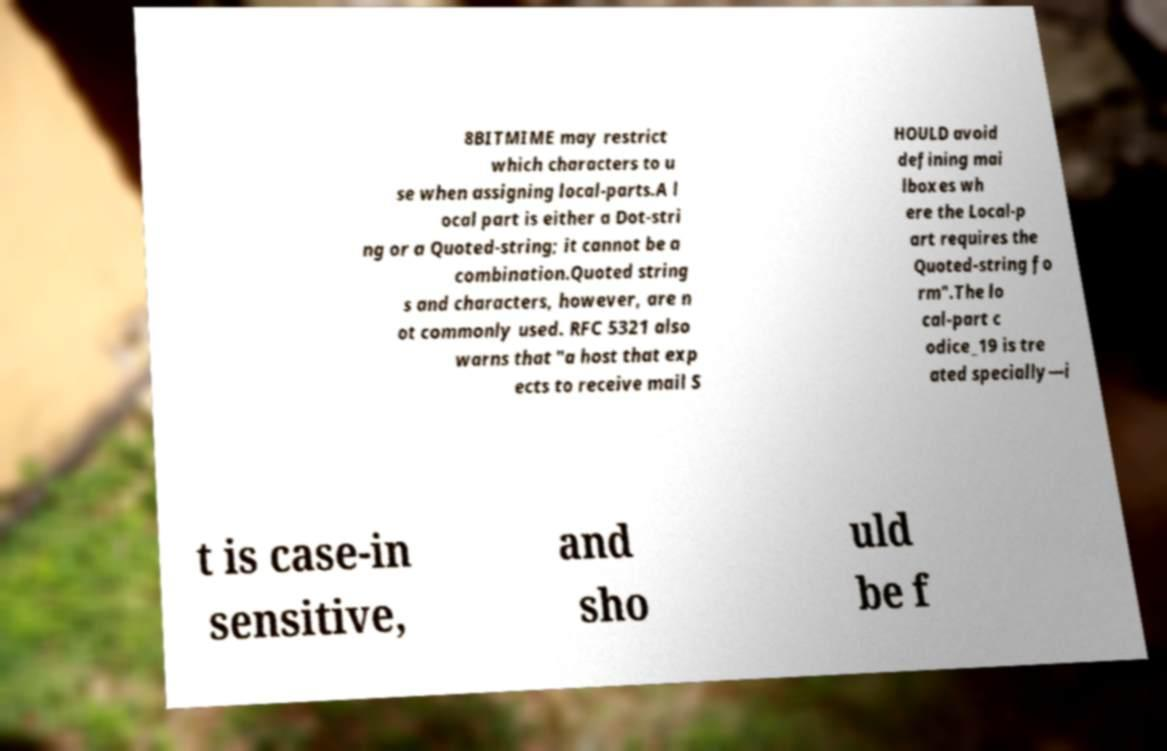Could you extract and type out the text from this image? 8BITMIME may restrict which characters to u se when assigning local-parts.A l ocal part is either a Dot-stri ng or a Quoted-string; it cannot be a combination.Quoted string s and characters, however, are n ot commonly used. RFC 5321 also warns that "a host that exp ects to receive mail S HOULD avoid defining mai lboxes wh ere the Local-p art requires the Quoted-string fo rm".The lo cal-part c odice_19 is tre ated specially—i t is case-in sensitive, and sho uld be f 